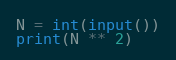Convert code to text. <code><loc_0><loc_0><loc_500><loc_500><_Python_>N = int(input())
print(N ** 2)

</code> 